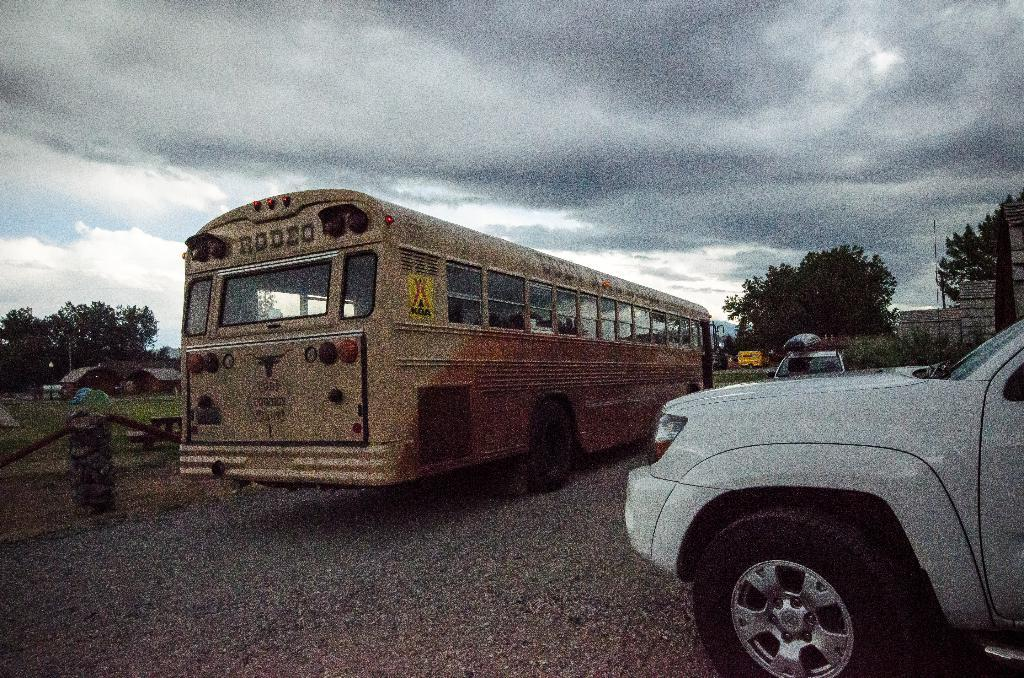<image>
Write a terse but informative summary of the picture. A dirty school bus that says, "Rodeo" on the back is parked to the left of a white truck. 